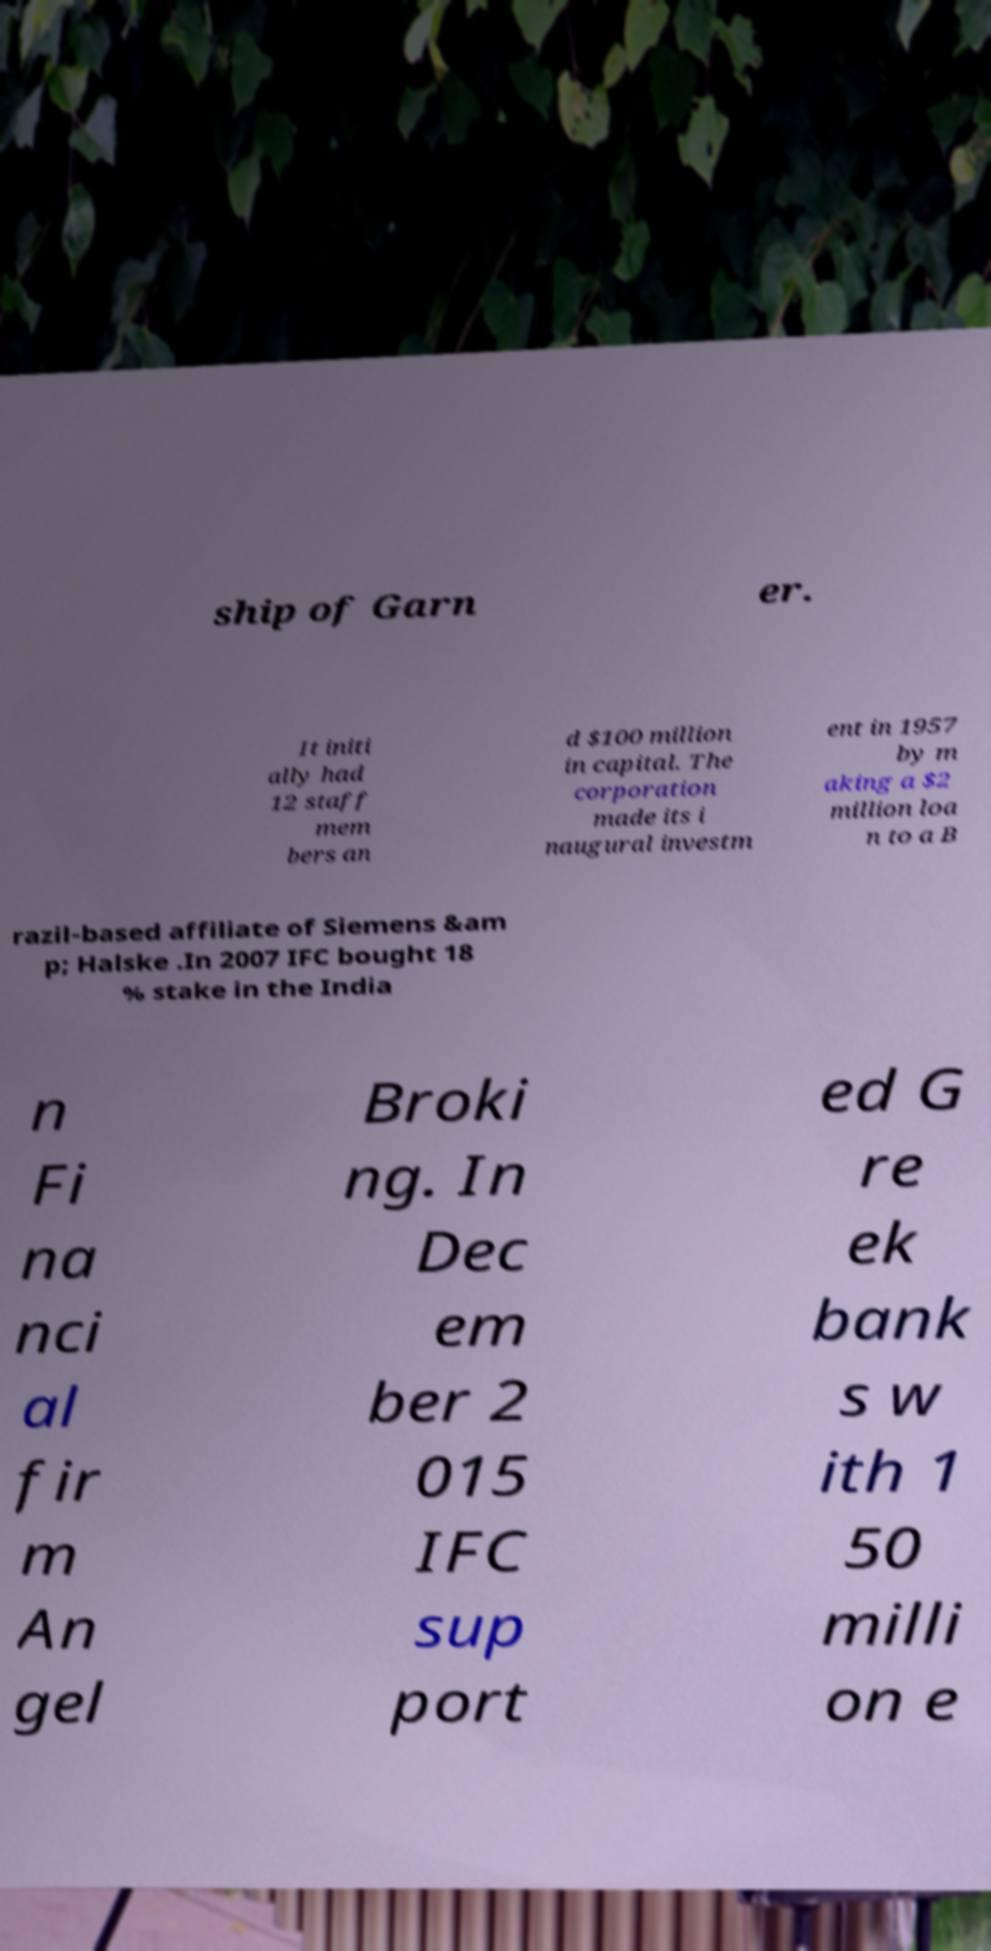Could you assist in decoding the text presented in this image and type it out clearly? ship of Garn er. It initi ally had 12 staff mem bers an d $100 million in capital. The corporation made its i naugural investm ent in 1957 by m aking a $2 million loa n to a B razil-based affiliate of Siemens &am p; Halske .In 2007 IFC bought 18 % stake in the India n Fi na nci al fir m An gel Broki ng. In Dec em ber 2 015 IFC sup port ed G re ek bank s w ith 1 50 milli on e 